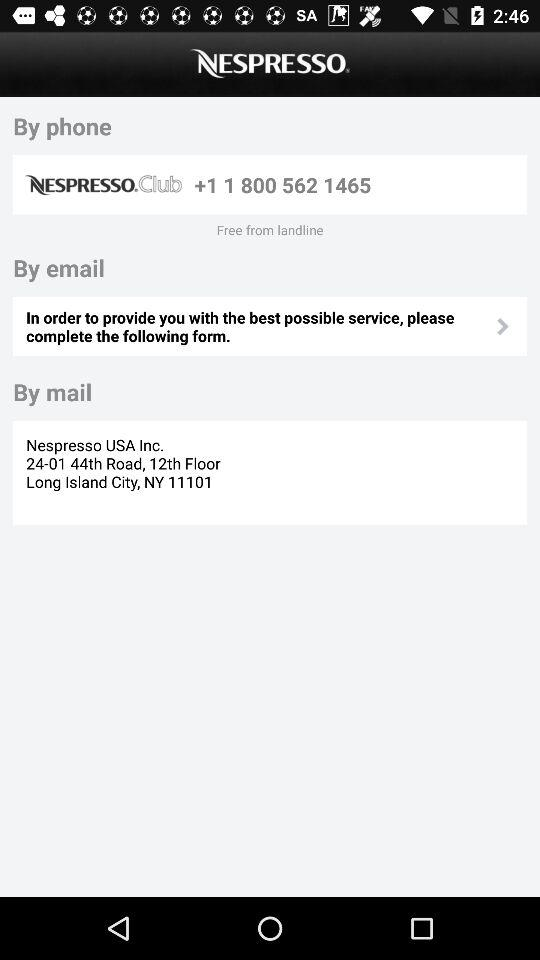How many contact methods are available by phone?
Answer the question using a single word or phrase. 1 